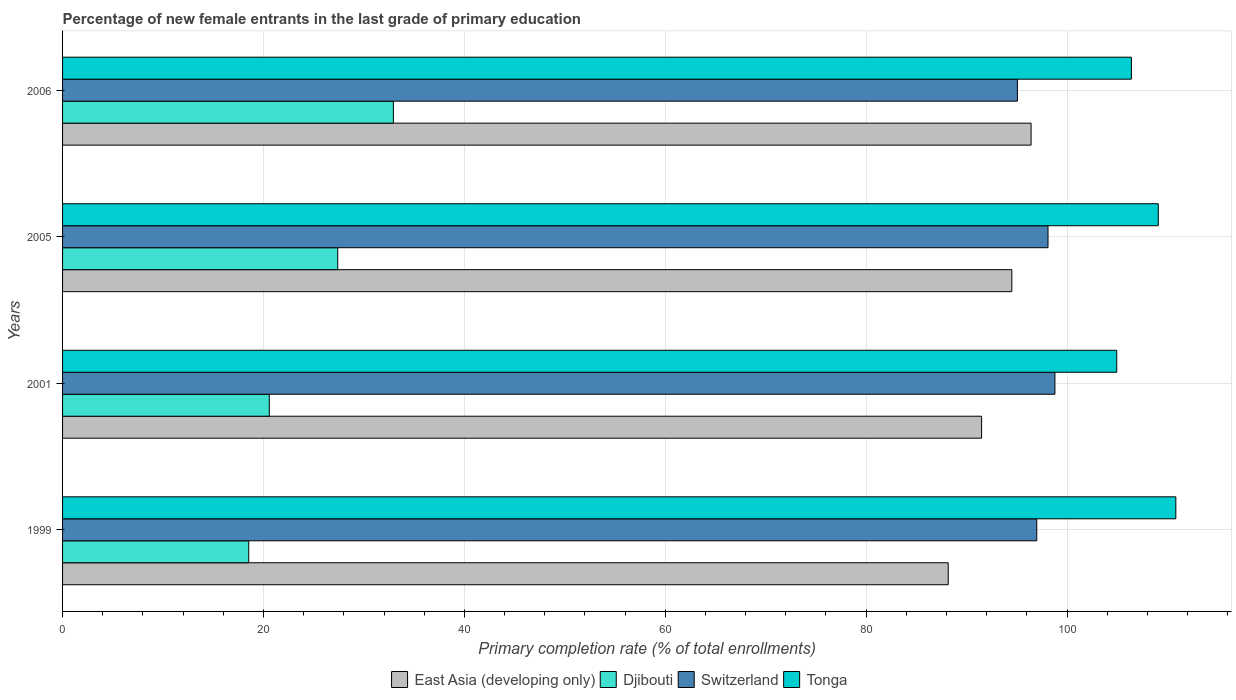How many groups of bars are there?
Offer a terse response. 4. Are the number of bars on each tick of the Y-axis equal?
Offer a very short reply. Yes. How many bars are there on the 4th tick from the top?
Your response must be concise. 4. How many bars are there on the 2nd tick from the bottom?
Your response must be concise. 4. What is the label of the 2nd group of bars from the top?
Provide a succinct answer. 2005. In how many cases, is the number of bars for a given year not equal to the number of legend labels?
Provide a succinct answer. 0. What is the percentage of new female entrants in East Asia (developing only) in 2005?
Provide a short and direct response. 94.5. Across all years, what is the maximum percentage of new female entrants in Switzerland?
Ensure brevity in your answer.  98.79. Across all years, what is the minimum percentage of new female entrants in Switzerland?
Give a very brief answer. 95.06. In which year was the percentage of new female entrants in Djibouti maximum?
Your answer should be compact. 2006. What is the total percentage of new female entrants in Djibouti in the graph?
Offer a terse response. 99.45. What is the difference between the percentage of new female entrants in Switzerland in 2001 and that in 2005?
Provide a short and direct response. 0.69. What is the difference between the percentage of new female entrants in Djibouti in 2006 and the percentage of new female entrants in East Asia (developing only) in 1999?
Ensure brevity in your answer.  -55.24. What is the average percentage of new female entrants in Switzerland per year?
Make the answer very short. 97.24. In the year 2005, what is the difference between the percentage of new female entrants in Djibouti and percentage of new female entrants in Tonga?
Make the answer very short. -81.69. What is the ratio of the percentage of new female entrants in Tonga in 2001 to that in 2006?
Provide a short and direct response. 0.99. Is the difference between the percentage of new female entrants in Djibouti in 2001 and 2006 greater than the difference between the percentage of new female entrants in Tonga in 2001 and 2006?
Ensure brevity in your answer.  No. What is the difference between the highest and the second highest percentage of new female entrants in Switzerland?
Offer a very short reply. 0.69. What is the difference between the highest and the lowest percentage of new female entrants in Tonga?
Your answer should be very brief. 5.88. Is the sum of the percentage of new female entrants in Switzerland in 1999 and 2005 greater than the maximum percentage of new female entrants in Djibouti across all years?
Ensure brevity in your answer.  Yes. Is it the case that in every year, the sum of the percentage of new female entrants in Djibouti and percentage of new female entrants in Switzerland is greater than the sum of percentage of new female entrants in East Asia (developing only) and percentage of new female entrants in Tonga?
Your answer should be very brief. No. What does the 2nd bar from the top in 2005 represents?
Give a very brief answer. Switzerland. What does the 4th bar from the bottom in 1999 represents?
Your answer should be compact. Tonga. Is it the case that in every year, the sum of the percentage of new female entrants in Djibouti and percentage of new female entrants in Switzerland is greater than the percentage of new female entrants in Tonga?
Keep it short and to the point. Yes. How many years are there in the graph?
Offer a terse response. 4. What is the difference between two consecutive major ticks on the X-axis?
Provide a succinct answer. 20. Does the graph contain grids?
Provide a succinct answer. Yes. How many legend labels are there?
Offer a terse response. 4. How are the legend labels stacked?
Ensure brevity in your answer.  Horizontal. What is the title of the graph?
Your response must be concise. Percentage of new female entrants in the last grade of primary education. What is the label or title of the X-axis?
Keep it short and to the point. Primary completion rate (% of total enrollments). What is the Primary completion rate (% of total enrollments) in East Asia (developing only) in 1999?
Your response must be concise. 88.17. What is the Primary completion rate (% of total enrollments) of Djibouti in 1999?
Make the answer very short. 18.54. What is the Primary completion rate (% of total enrollments) of Switzerland in 1999?
Keep it short and to the point. 96.99. What is the Primary completion rate (% of total enrollments) in Tonga in 1999?
Your answer should be compact. 110.83. What is the Primary completion rate (% of total enrollments) of East Asia (developing only) in 2001?
Your answer should be compact. 91.49. What is the Primary completion rate (% of total enrollments) of Djibouti in 2001?
Your response must be concise. 20.58. What is the Primary completion rate (% of total enrollments) in Switzerland in 2001?
Your answer should be very brief. 98.79. What is the Primary completion rate (% of total enrollments) of Tonga in 2001?
Keep it short and to the point. 104.95. What is the Primary completion rate (% of total enrollments) in East Asia (developing only) in 2005?
Provide a succinct answer. 94.5. What is the Primary completion rate (% of total enrollments) in Djibouti in 2005?
Ensure brevity in your answer.  27.4. What is the Primary completion rate (% of total enrollments) of Switzerland in 2005?
Ensure brevity in your answer.  98.11. What is the Primary completion rate (% of total enrollments) of Tonga in 2005?
Keep it short and to the point. 109.08. What is the Primary completion rate (% of total enrollments) in East Asia (developing only) in 2006?
Your answer should be very brief. 96.42. What is the Primary completion rate (% of total enrollments) in Djibouti in 2006?
Provide a short and direct response. 32.93. What is the Primary completion rate (% of total enrollments) in Switzerland in 2006?
Your answer should be compact. 95.06. What is the Primary completion rate (% of total enrollments) in Tonga in 2006?
Ensure brevity in your answer.  106.41. Across all years, what is the maximum Primary completion rate (% of total enrollments) of East Asia (developing only)?
Give a very brief answer. 96.42. Across all years, what is the maximum Primary completion rate (% of total enrollments) of Djibouti?
Offer a very short reply. 32.93. Across all years, what is the maximum Primary completion rate (% of total enrollments) in Switzerland?
Offer a terse response. 98.79. Across all years, what is the maximum Primary completion rate (% of total enrollments) of Tonga?
Your answer should be compact. 110.83. Across all years, what is the minimum Primary completion rate (% of total enrollments) of East Asia (developing only)?
Make the answer very short. 88.17. Across all years, what is the minimum Primary completion rate (% of total enrollments) of Djibouti?
Your answer should be very brief. 18.54. Across all years, what is the minimum Primary completion rate (% of total enrollments) of Switzerland?
Keep it short and to the point. 95.06. Across all years, what is the minimum Primary completion rate (% of total enrollments) in Tonga?
Your answer should be compact. 104.95. What is the total Primary completion rate (% of total enrollments) in East Asia (developing only) in the graph?
Ensure brevity in your answer.  370.59. What is the total Primary completion rate (% of total enrollments) of Djibouti in the graph?
Give a very brief answer. 99.45. What is the total Primary completion rate (% of total enrollments) in Switzerland in the graph?
Your answer should be compact. 388.95. What is the total Primary completion rate (% of total enrollments) in Tonga in the graph?
Ensure brevity in your answer.  431.27. What is the difference between the Primary completion rate (% of total enrollments) of East Asia (developing only) in 1999 and that in 2001?
Give a very brief answer. -3.32. What is the difference between the Primary completion rate (% of total enrollments) in Djibouti in 1999 and that in 2001?
Your response must be concise. -2.05. What is the difference between the Primary completion rate (% of total enrollments) in Switzerland in 1999 and that in 2001?
Your answer should be very brief. -1.81. What is the difference between the Primary completion rate (% of total enrollments) in Tonga in 1999 and that in 2001?
Your answer should be very brief. 5.88. What is the difference between the Primary completion rate (% of total enrollments) of East Asia (developing only) in 1999 and that in 2005?
Provide a succinct answer. -6.33. What is the difference between the Primary completion rate (% of total enrollments) in Djibouti in 1999 and that in 2005?
Ensure brevity in your answer.  -8.86. What is the difference between the Primary completion rate (% of total enrollments) of Switzerland in 1999 and that in 2005?
Your answer should be very brief. -1.12. What is the difference between the Primary completion rate (% of total enrollments) in Tonga in 1999 and that in 2005?
Give a very brief answer. 1.75. What is the difference between the Primary completion rate (% of total enrollments) of East Asia (developing only) in 1999 and that in 2006?
Your answer should be very brief. -8.25. What is the difference between the Primary completion rate (% of total enrollments) in Djibouti in 1999 and that in 2006?
Offer a very short reply. -14.4. What is the difference between the Primary completion rate (% of total enrollments) in Switzerland in 1999 and that in 2006?
Your response must be concise. 1.93. What is the difference between the Primary completion rate (% of total enrollments) in Tonga in 1999 and that in 2006?
Offer a very short reply. 4.42. What is the difference between the Primary completion rate (% of total enrollments) in East Asia (developing only) in 2001 and that in 2005?
Your answer should be compact. -3.01. What is the difference between the Primary completion rate (% of total enrollments) of Djibouti in 2001 and that in 2005?
Ensure brevity in your answer.  -6.82. What is the difference between the Primary completion rate (% of total enrollments) of Switzerland in 2001 and that in 2005?
Offer a terse response. 0.69. What is the difference between the Primary completion rate (% of total enrollments) of Tonga in 2001 and that in 2005?
Provide a succinct answer. -4.14. What is the difference between the Primary completion rate (% of total enrollments) of East Asia (developing only) in 2001 and that in 2006?
Offer a very short reply. -4.93. What is the difference between the Primary completion rate (% of total enrollments) of Djibouti in 2001 and that in 2006?
Give a very brief answer. -12.35. What is the difference between the Primary completion rate (% of total enrollments) in Switzerland in 2001 and that in 2006?
Offer a terse response. 3.73. What is the difference between the Primary completion rate (% of total enrollments) in Tonga in 2001 and that in 2006?
Your answer should be compact. -1.46. What is the difference between the Primary completion rate (% of total enrollments) of East Asia (developing only) in 2005 and that in 2006?
Ensure brevity in your answer.  -1.92. What is the difference between the Primary completion rate (% of total enrollments) of Djibouti in 2005 and that in 2006?
Ensure brevity in your answer.  -5.53. What is the difference between the Primary completion rate (% of total enrollments) in Switzerland in 2005 and that in 2006?
Offer a terse response. 3.05. What is the difference between the Primary completion rate (% of total enrollments) of Tonga in 2005 and that in 2006?
Provide a succinct answer. 2.68. What is the difference between the Primary completion rate (% of total enrollments) in East Asia (developing only) in 1999 and the Primary completion rate (% of total enrollments) in Djibouti in 2001?
Your response must be concise. 67.59. What is the difference between the Primary completion rate (% of total enrollments) of East Asia (developing only) in 1999 and the Primary completion rate (% of total enrollments) of Switzerland in 2001?
Make the answer very short. -10.62. What is the difference between the Primary completion rate (% of total enrollments) in East Asia (developing only) in 1999 and the Primary completion rate (% of total enrollments) in Tonga in 2001?
Keep it short and to the point. -16.77. What is the difference between the Primary completion rate (% of total enrollments) of Djibouti in 1999 and the Primary completion rate (% of total enrollments) of Switzerland in 2001?
Provide a short and direct response. -80.26. What is the difference between the Primary completion rate (% of total enrollments) in Djibouti in 1999 and the Primary completion rate (% of total enrollments) in Tonga in 2001?
Your response must be concise. -86.41. What is the difference between the Primary completion rate (% of total enrollments) of Switzerland in 1999 and the Primary completion rate (% of total enrollments) of Tonga in 2001?
Your answer should be compact. -7.96. What is the difference between the Primary completion rate (% of total enrollments) of East Asia (developing only) in 1999 and the Primary completion rate (% of total enrollments) of Djibouti in 2005?
Ensure brevity in your answer.  60.77. What is the difference between the Primary completion rate (% of total enrollments) of East Asia (developing only) in 1999 and the Primary completion rate (% of total enrollments) of Switzerland in 2005?
Ensure brevity in your answer.  -9.93. What is the difference between the Primary completion rate (% of total enrollments) of East Asia (developing only) in 1999 and the Primary completion rate (% of total enrollments) of Tonga in 2005?
Offer a terse response. -20.91. What is the difference between the Primary completion rate (% of total enrollments) of Djibouti in 1999 and the Primary completion rate (% of total enrollments) of Switzerland in 2005?
Provide a succinct answer. -79.57. What is the difference between the Primary completion rate (% of total enrollments) of Djibouti in 1999 and the Primary completion rate (% of total enrollments) of Tonga in 2005?
Provide a succinct answer. -90.55. What is the difference between the Primary completion rate (% of total enrollments) in Switzerland in 1999 and the Primary completion rate (% of total enrollments) in Tonga in 2005?
Your response must be concise. -12.1. What is the difference between the Primary completion rate (% of total enrollments) in East Asia (developing only) in 1999 and the Primary completion rate (% of total enrollments) in Djibouti in 2006?
Keep it short and to the point. 55.24. What is the difference between the Primary completion rate (% of total enrollments) in East Asia (developing only) in 1999 and the Primary completion rate (% of total enrollments) in Switzerland in 2006?
Give a very brief answer. -6.89. What is the difference between the Primary completion rate (% of total enrollments) in East Asia (developing only) in 1999 and the Primary completion rate (% of total enrollments) in Tonga in 2006?
Give a very brief answer. -18.23. What is the difference between the Primary completion rate (% of total enrollments) of Djibouti in 1999 and the Primary completion rate (% of total enrollments) of Switzerland in 2006?
Ensure brevity in your answer.  -76.52. What is the difference between the Primary completion rate (% of total enrollments) in Djibouti in 1999 and the Primary completion rate (% of total enrollments) in Tonga in 2006?
Ensure brevity in your answer.  -87.87. What is the difference between the Primary completion rate (% of total enrollments) in Switzerland in 1999 and the Primary completion rate (% of total enrollments) in Tonga in 2006?
Offer a terse response. -9.42. What is the difference between the Primary completion rate (% of total enrollments) of East Asia (developing only) in 2001 and the Primary completion rate (% of total enrollments) of Djibouti in 2005?
Your response must be concise. 64.1. What is the difference between the Primary completion rate (% of total enrollments) in East Asia (developing only) in 2001 and the Primary completion rate (% of total enrollments) in Switzerland in 2005?
Offer a very short reply. -6.61. What is the difference between the Primary completion rate (% of total enrollments) in East Asia (developing only) in 2001 and the Primary completion rate (% of total enrollments) in Tonga in 2005?
Give a very brief answer. -17.59. What is the difference between the Primary completion rate (% of total enrollments) of Djibouti in 2001 and the Primary completion rate (% of total enrollments) of Switzerland in 2005?
Keep it short and to the point. -77.53. What is the difference between the Primary completion rate (% of total enrollments) in Djibouti in 2001 and the Primary completion rate (% of total enrollments) in Tonga in 2005?
Give a very brief answer. -88.5. What is the difference between the Primary completion rate (% of total enrollments) in Switzerland in 2001 and the Primary completion rate (% of total enrollments) in Tonga in 2005?
Your answer should be compact. -10.29. What is the difference between the Primary completion rate (% of total enrollments) of East Asia (developing only) in 2001 and the Primary completion rate (% of total enrollments) of Djibouti in 2006?
Keep it short and to the point. 58.56. What is the difference between the Primary completion rate (% of total enrollments) of East Asia (developing only) in 2001 and the Primary completion rate (% of total enrollments) of Switzerland in 2006?
Your response must be concise. -3.57. What is the difference between the Primary completion rate (% of total enrollments) of East Asia (developing only) in 2001 and the Primary completion rate (% of total enrollments) of Tonga in 2006?
Ensure brevity in your answer.  -14.91. What is the difference between the Primary completion rate (% of total enrollments) in Djibouti in 2001 and the Primary completion rate (% of total enrollments) in Switzerland in 2006?
Your answer should be compact. -74.48. What is the difference between the Primary completion rate (% of total enrollments) in Djibouti in 2001 and the Primary completion rate (% of total enrollments) in Tonga in 2006?
Make the answer very short. -85.83. What is the difference between the Primary completion rate (% of total enrollments) of Switzerland in 2001 and the Primary completion rate (% of total enrollments) of Tonga in 2006?
Your answer should be very brief. -7.61. What is the difference between the Primary completion rate (% of total enrollments) in East Asia (developing only) in 2005 and the Primary completion rate (% of total enrollments) in Djibouti in 2006?
Your answer should be very brief. 61.57. What is the difference between the Primary completion rate (% of total enrollments) of East Asia (developing only) in 2005 and the Primary completion rate (% of total enrollments) of Switzerland in 2006?
Ensure brevity in your answer.  -0.55. What is the difference between the Primary completion rate (% of total enrollments) in East Asia (developing only) in 2005 and the Primary completion rate (% of total enrollments) in Tonga in 2006?
Keep it short and to the point. -11.9. What is the difference between the Primary completion rate (% of total enrollments) of Djibouti in 2005 and the Primary completion rate (% of total enrollments) of Switzerland in 2006?
Your response must be concise. -67.66. What is the difference between the Primary completion rate (% of total enrollments) in Djibouti in 2005 and the Primary completion rate (% of total enrollments) in Tonga in 2006?
Give a very brief answer. -79.01. What is the difference between the Primary completion rate (% of total enrollments) of Switzerland in 2005 and the Primary completion rate (% of total enrollments) of Tonga in 2006?
Your answer should be very brief. -8.3. What is the average Primary completion rate (% of total enrollments) of East Asia (developing only) per year?
Your answer should be compact. 92.65. What is the average Primary completion rate (% of total enrollments) of Djibouti per year?
Offer a very short reply. 24.86. What is the average Primary completion rate (% of total enrollments) of Switzerland per year?
Give a very brief answer. 97.24. What is the average Primary completion rate (% of total enrollments) of Tonga per year?
Give a very brief answer. 107.82. In the year 1999, what is the difference between the Primary completion rate (% of total enrollments) of East Asia (developing only) and Primary completion rate (% of total enrollments) of Djibouti?
Make the answer very short. 69.64. In the year 1999, what is the difference between the Primary completion rate (% of total enrollments) in East Asia (developing only) and Primary completion rate (% of total enrollments) in Switzerland?
Your response must be concise. -8.81. In the year 1999, what is the difference between the Primary completion rate (% of total enrollments) in East Asia (developing only) and Primary completion rate (% of total enrollments) in Tonga?
Offer a very short reply. -22.66. In the year 1999, what is the difference between the Primary completion rate (% of total enrollments) of Djibouti and Primary completion rate (% of total enrollments) of Switzerland?
Offer a terse response. -78.45. In the year 1999, what is the difference between the Primary completion rate (% of total enrollments) in Djibouti and Primary completion rate (% of total enrollments) in Tonga?
Your answer should be compact. -92.3. In the year 1999, what is the difference between the Primary completion rate (% of total enrollments) of Switzerland and Primary completion rate (% of total enrollments) of Tonga?
Your response must be concise. -13.84. In the year 2001, what is the difference between the Primary completion rate (% of total enrollments) of East Asia (developing only) and Primary completion rate (% of total enrollments) of Djibouti?
Your response must be concise. 70.91. In the year 2001, what is the difference between the Primary completion rate (% of total enrollments) of East Asia (developing only) and Primary completion rate (% of total enrollments) of Switzerland?
Ensure brevity in your answer.  -7.3. In the year 2001, what is the difference between the Primary completion rate (% of total enrollments) in East Asia (developing only) and Primary completion rate (% of total enrollments) in Tonga?
Provide a short and direct response. -13.45. In the year 2001, what is the difference between the Primary completion rate (% of total enrollments) of Djibouti and Primary completion rate (% of total enrollments) of Switzerland?
Provide a succinct answer. -78.21. In the year 2001, what is the difference between the Primary completion rate (% of total enrollments) of Djibouti and Primary completion rate (% of total enrollments) of Tonga?
Make the answer very short. -84.37. In the year 2001, what is the difference between the Primary completion rate (% of total enrollments) in Switzerland and Primary completion rate (% of total enrollments) in Tonga?
Keep it short and to the point. -6.15. In the year 2005, what is the difference between the Primary completion rate (% of total enrollments) of East Asia (developing only) and Primary completion rate (% of total enrollments) of Djibouti?
Provide a short and direct response. 67.11. In the year 2005, what is the difference between the Primary completion rate (% of total enrollments) in East Asia (developing only) and Primary completion rate (% of total enrollments) in Switzerland?
Offer a terse response. -3.6. In the year 2005, what is the difference between the Primary completion rate (% of total enrollments) in East Asia (developing only) and Primary completion rate (% of total enrollments) in Tonga?
Your answer should be compact. -14.58. In the year 2005, what is the difference between the Primary completion rate (% of total enrollments) of Djibouti and Primary completion rate (% of total enrollments) of Switzerland?
Keep it short and to the point. -70.71. In the year 2005, what is the difference between the Primary completion rate (% of total enrollments) of Djibouti and Primary completion rate (% of total enrollments) of Tonga?
Your response must be concise. -81.69. In the year 2005, what is the difference between the Primary completion rate (% of total enrollments) of Switzerland and Primary completion rate (% of total enrollments) of Tonga?
Your answer should be very brief. -10.98. In the year 2006, what is the difference between the Primary completion rate (% of total enrollments) in East Asia (developing only) and Primary completion rate (% of total enrollments) in Djibouti?
Keep it short and to the point. 63.49. In the year 2006, what is the difference between the Primary completion rate (% of total enrollments) of East Asia (developing only) and Primary completion rate (% of total enrollments) of Switzerland?
Your response must be concise. 1.36. In the year 2006, what is the difference between the Primary completion rate (% of total enrollments) of East Asia (developing only) and Primary completion rate (% of total enrollments) of Tonga?
Your answer should be compact. -9.99. In the year 2006, what is the difference between the Primary completion rate (% of total enrollments) in Djibouti and Primary completion rate (% of total enrollments) in Switzerland?
Your answer should be compact. -62.13. In the year 2006, what is the difference between the Primary completion rate (% of total enrollments) in Djibouti and Primary completion rate (% of total enrollments) in Tonga?
Your answer should be very brief. -73.48. In the year 2006, what is the difference between the Primary completion rate (% of total enrollments) of Switzerland and Primary completion rate (% of total enrollments) of Tonga?
Ensure brevity in your answer.  -11.35. What is the ratio of the Primary completion rate (% of total enrollments) in East Asia (developing only) in 1999 to that in 2001?
Provide a succinct answer. 0.96. What is the ratio of the Primary completion rate (% of total enrollments) in Djibouti in 1999 to that in 2001?
Your answer should be very brief. 0.9. What is the ratio of the Primary completion rate (% of total enrollments) of Switzerland in 1999 to that in 2001?
Keep it short and to the point. 0.98. What is the ratio of the Primary completion rate (% of total enrollments) of Tonga in 1999 to that in 2001?
Offer a terse response. 1.06. What is the ratio of the Primary completion rate (% of total enrollments) of East Asia (developing only) in 1999 to that in 2005?
Your response must be concise. 0.93. What is the ratio of the Primary completion rate (% of total enrollments) of Djibouti in 1999 to that in 2005?
Provide a short and direct response. 0.68. What is the ratio of the Primary completion rate (% of total enrollments) of Tonga in 1999 to that in 2005?
Your response must be concise. 1.02. What is the ratio of the Primary completion rate (% of total enrollments) of East Asia (developing only) in 1999 to that in 2006?
Ensure brevity in your answer.  0.91. What is the ratio of the Primary completion rate (% of total enrollments) in Djibouti in 1999 to that in 2006?
Offer a very short reply. 0.56. What is the ratio of the Primary completion rate (% of total enrollments) of Switzerland in 1999 to that in 2006?
Provide a succinct answer. 1.02. What is the ratio of the Primary completion rate (% of total enrollments) of Tonga in 1999 to that in 2006?
Ensure brevity in your answer.  1.04. What is the ratio of the Primary completion rate (% of total enrollments) in East Asia (developing only) in 2001 to that in 2005?
Ensure brevity in your answer.  0.97. What is the ratio of the Primary completion rate (% of total enrollments) in Djibouti in 2001 to that in 2005?
Give a very brief answer. 0.75. What is the ratio of the Primary completion rate (% of total enrollments) in Switzerland in 2001 to that in 2005?
Keep it short and to the point. 1.01. What is the ratio of the Primary completion rate (% of total enrollments) in Tonga in 2001 to that in 2005?
Keep it short and to the point. 0.96. What is the ratio of the Primary completion rate (% of total enrollments) of East Asia (developing only) in 2001 to that in 2006?
Ensure brevity in your answer.  0.95. What is the ratio of the Primary completion rate (% of total enrollments) in Djibouti in 2001 to that in 2006?
Provide a succinct answer. 0.62. What is the ratio of the Primary completion rate (% of total enrollments) in Switzerland in 2001 to that in 2006?
Your answer should be compact. 1.04. What is the ratio of the Primary completion rate (% of total enrollments) of Tonga in 2001 to that in 2006?
Ensure brevity in your answer.  0.99. What is the ratio of the Primary completion rate (% of total enrollments) of East Asia (developing only) in 2005 to that in 2006?
Keep it short and to the point. 0.98. What is the ratio of the Primary completion rate (% of total enrollments) in Djibouti in 2005 to that in 2006?
Your response must be concise. 0.83. What is the ratio of the Primary completion rate (% of total enrollments) in Switzerland in 2005 to that in 2006?
Offer a very short reply. 1.03. What is the ratio of the Primary completion rate (% of total enrollments) in Tonga in 2005 to that in 2006?
Keep it short and to the point. 1.03. What is the difference between the highest and the second highest Primary completion rate (% of total enrollments) of East Asia (developing only)?
Give a very brief answer. 1.92. What is the difference between the highest and the second highest Primary completion rate (% of total enrollments) of Djibouti?
Keep it short and to the point. 5.53. What is the difference between the highest and the second highest Primary completion rate (% of total enrollments) in Switzerland?
Your response must be concise. 0.69. What is the difference between the highest and the second highest Primary completion rate (% of total enrollments) in Tonga?
Your answer should be compact. 1.75. What is the difference between the highest and the lowest Primary completion rate (% of total enrollments) in East Asia (developing only)?
Ensure brevity in your answer.  8.25. What is the difference between the highest and the lowest Primary completion rate (% of total enrollments) of Djibouti?
Give a very brief answer. 14.4. What is the difference between the highest and the lowest Primary completion rate (% of total enrollments) of Switzerland?
Ensure brevity in your answer.  3.73. What is the difference between the highest and the lowest Primary completion rate (% of total enrollments) in Tonga?
Offer a terse response. 5.88. 